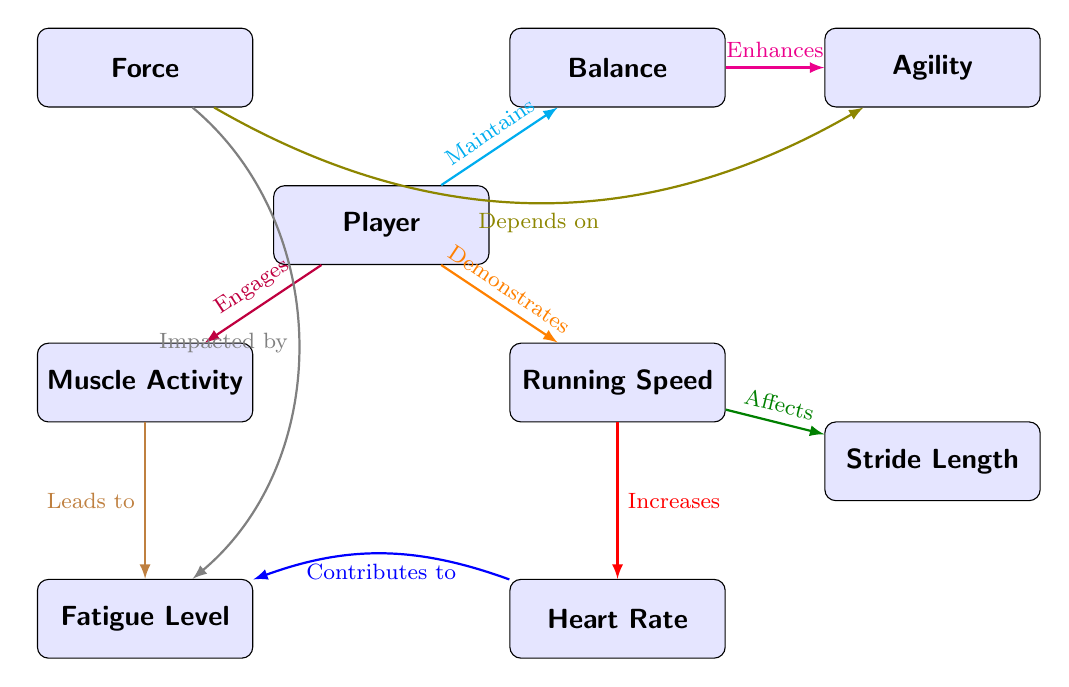What is the main node in the diagram? The main node in the diagram is "Player," which serves as the central entity from which various performance metrics are derived.
Answer: Player How many edges are connected to the "Balance" node? The "Balance" node is connected to two edges: one leading to "Agility" and one leading from "Player."
Answer: 2 What does "Running Speed" affect? "Running Speed" directly affects "Stride Length," establishing a relationship that indicates how speed can influence the physical distance covered in a single stride.
Answer: Stride Length Which node is impacted by "Fatigue Level"? The node impacted by "Fatigue Level" is "Force," as indicated by the relationship that suggests fatigue can diminish a player's force output.
Answer: Force What is the flow direction from "Muscle Activity" in the diagram? The flow direction from "Muscle Activity" leads downward to "Fatigue Level," showing that muscle engagement is connected to fatigue accumulation.
Answer: Downward What is the relationship between "Heart Rate" and "Fatigue Level"? The relationship is that "Heart Rate" contributes to "Fatigue Level," signifying that increased heart rates, often due to exertion, can heighten fatigue.
Answer: Contributes to Which metric demonstrates a direct relationship to "Running Speed"? "Stride Length" demonstrates a direct relationship to "Running Speed," suggesting that as speed increases, so does the length of each stride taken.
Answer: Stride Length How does "Agility" relate to "Force"? "Agility" depends on "Force," implying that a player's ability to be agile is influenced by how much force they can exert.
Answer: Depends on What color represents the relationship between "Player" and "Muscle Activity"? The relationship is represented by the color purple, indicating engagement with muscle activity stemming from the player.
Answer: Purple 